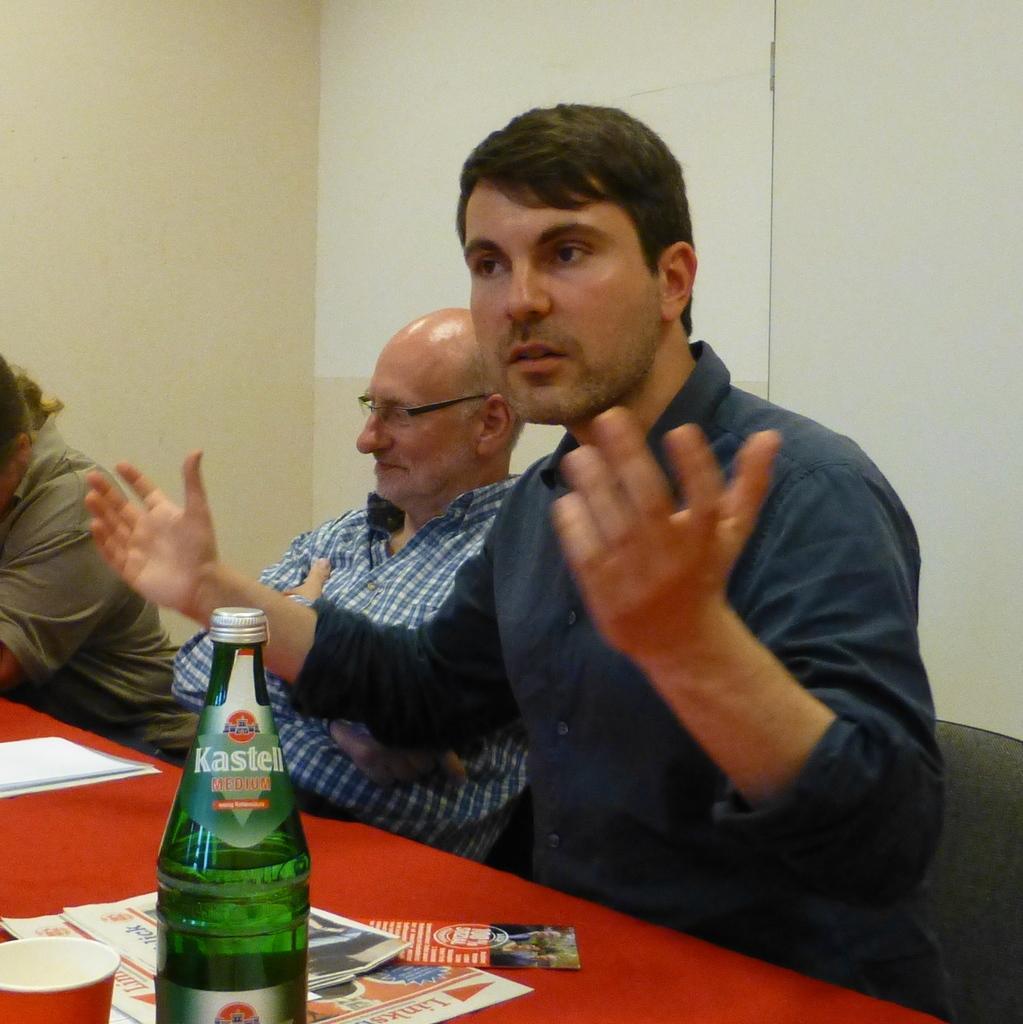Please provide a concise description of this image. In this picture there is a man who is wearing a blue shirt. There is also another man who is wearing a blue check shirt. And to the left side , there is also another person. There is a bottle on the table. There is a cup and newspaper on the table. There is a pamphlet placed on the table. 